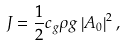<formula> <loc_0><loc_0><loc_500><loc_500>J = \frac { 1 } { 2 } c _ { g } \rho g \left | A _ { 0 } \right | ^ { 2 } ,</formula> 